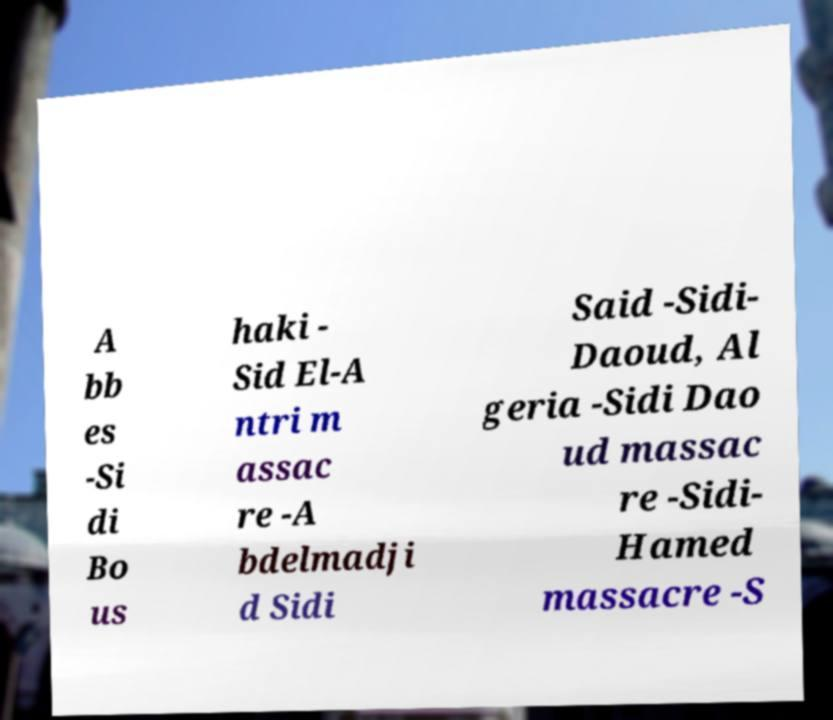What messages or text are displayed in this image? I need them in a readable, typed format. A bb es -Si di Bo us haki - Sid El-A ntri m assac re -A bdelmadji d Sidi Said -Sidi- Daoud, Al geria -Sidi Dao ud massac re -Sidi- Hamed massacre -S 